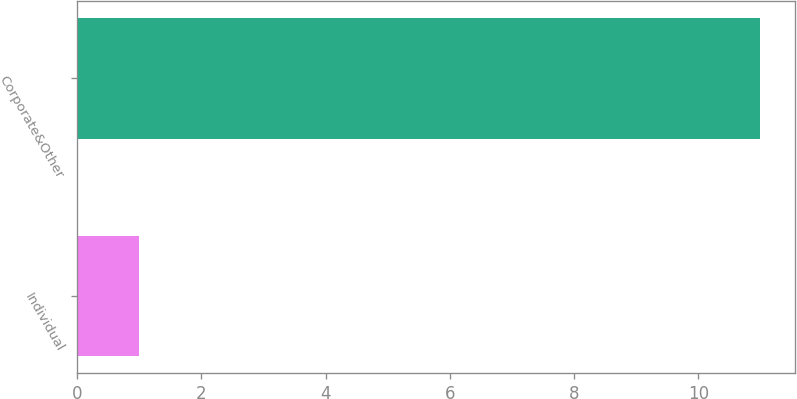Convert chart to OTSL. <chart><loc_0><loc_0><loc_500><loc_500><bar_chart><fcel>Individual<fcel>Corporate&Other<nl><fcel>1<fcel>11<nl></chart> 